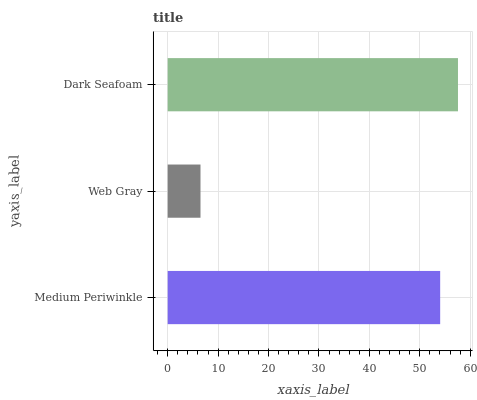Is Web Gray the minimum?
Answer yes or no. Yes. Is Dark Seafoam the maximum?
Answer yes or no. Yes. Is Dark Seafoam the minimum?
Answer yes or no. No. Is Web Gray the maximum?
Answer yes or no. No. Is Dark Seafoam greater than Web Gray?
Answer yes or no. Yes. Is Web Gray less than Dark Seafoam?
Answer yes or no. Yes. Is Web Gray greater than Dark Seafoam?
Answer yes or no. No. Is Dark Seafoam less than Web Gray?
Answer yes or no. No. Is Medium Periwinkle the high median?
Answer yes or no. Yes. Is Medium Periwinkle the low median?
Answer yes or no. Yes. Is Web Gray the high median?
Answer yes or no. No. Is Dark Seafoam the low median?
Answer yes or no. No. 